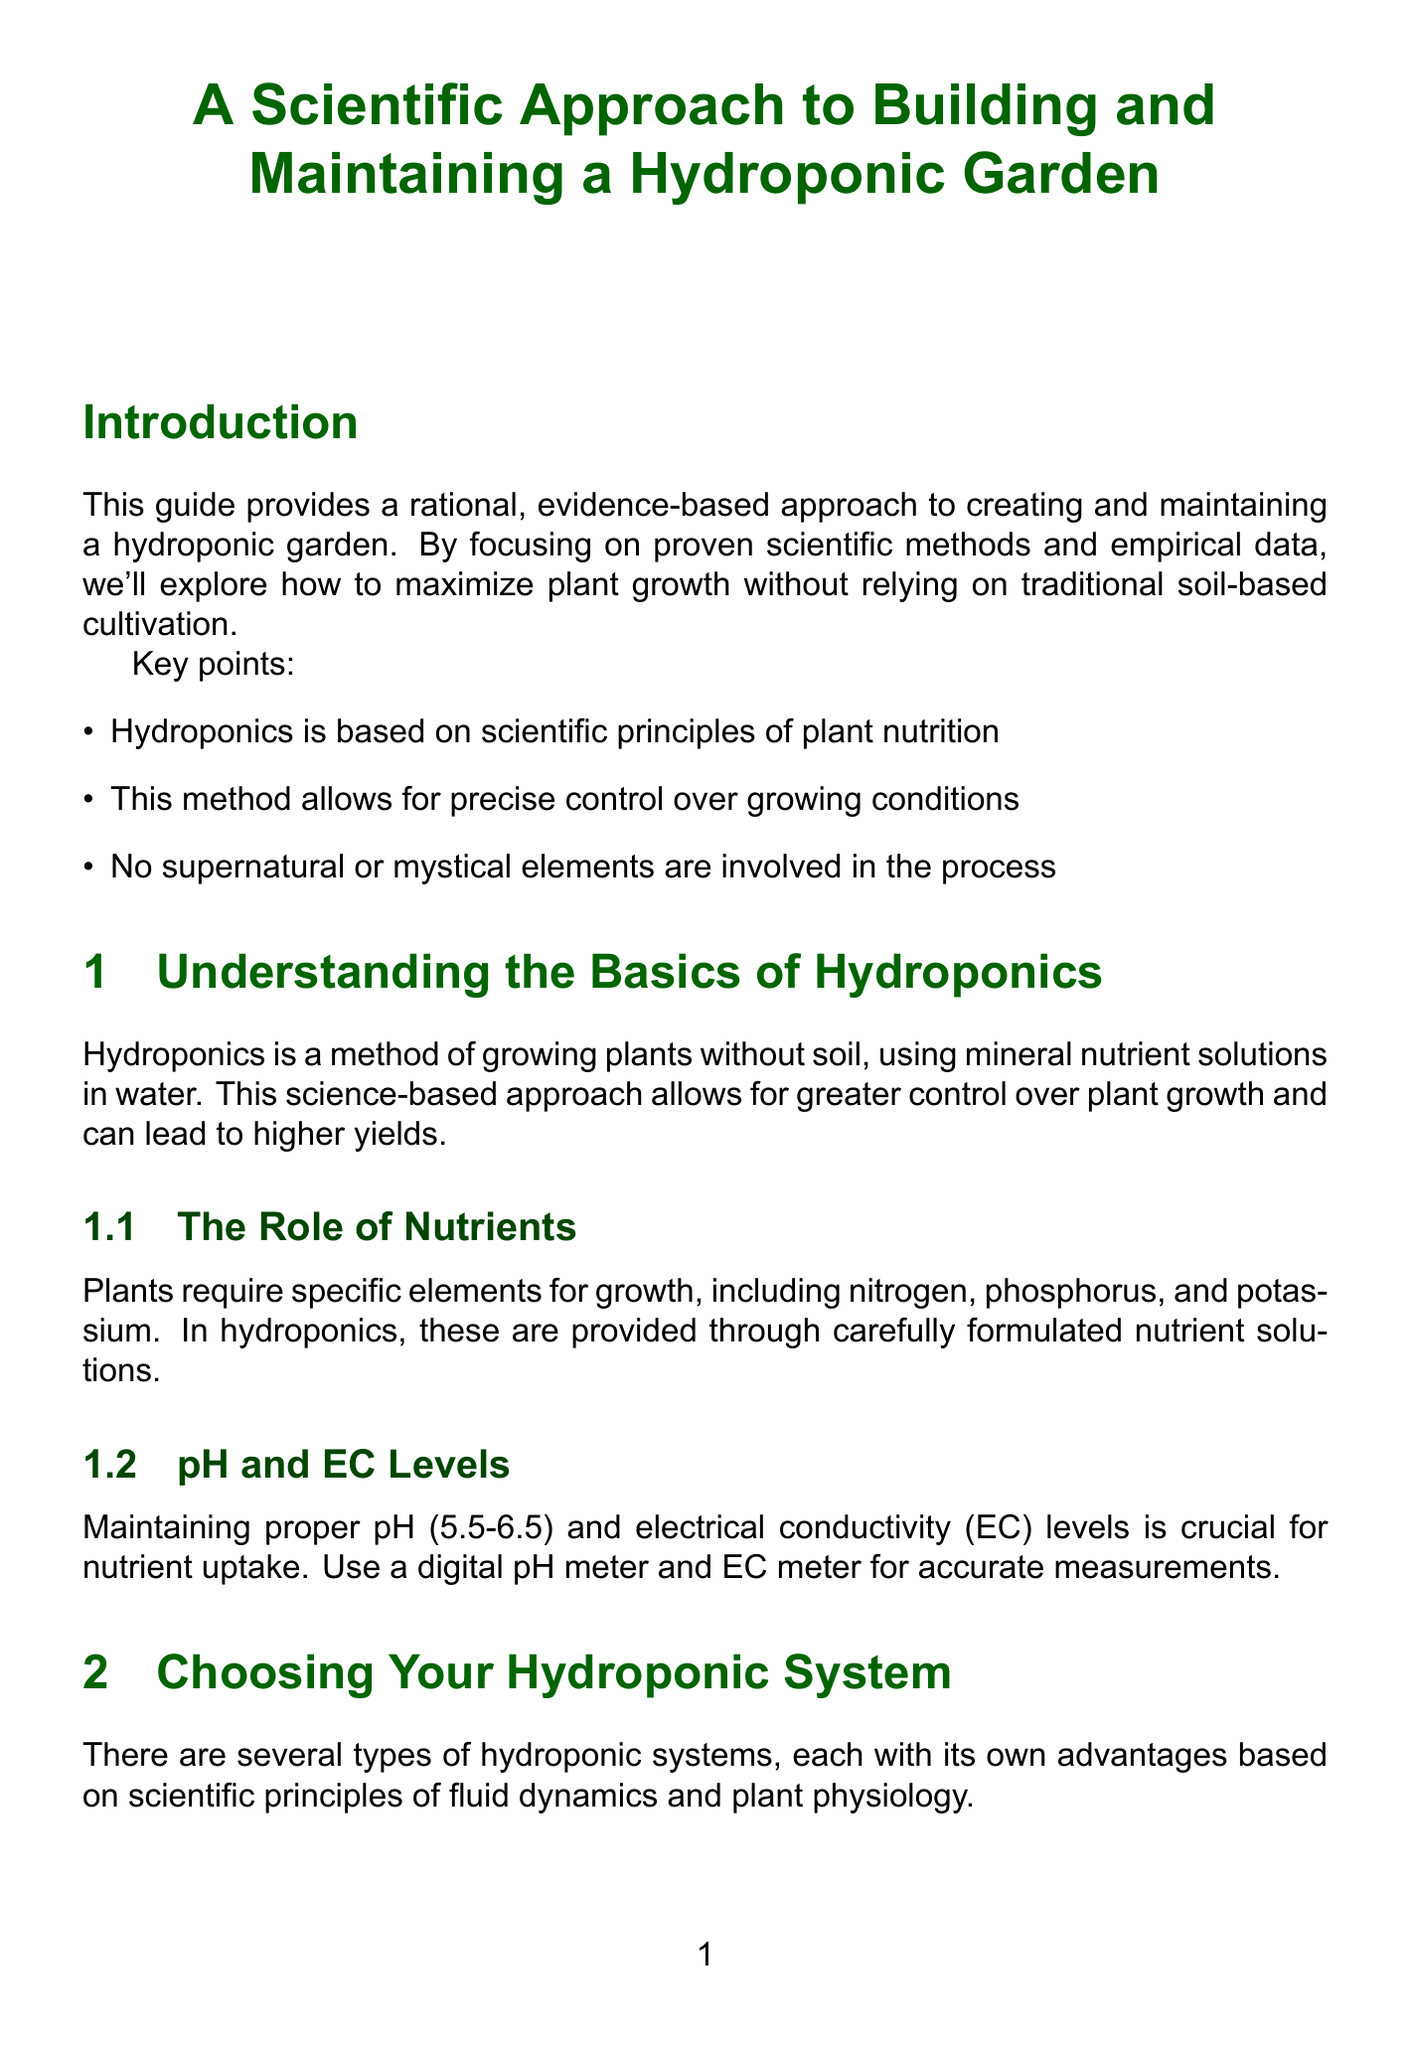what is the optimal pH range for hydroponics? The optimal pH range for hydroponics is crucial for nutrient uptake, which is 5.5-6.5.
Answer: 5.5-6.5 what type of plants are well-suited for hydroponic growth? Well-suited plants include leafy greens, herbs, and certain fruiting plants.
Answer: leafy greens, herbs, certain fruiting plants how many steps are involved in setting up a hydroponic garden? The process of setting up a hydroponic garden includes a series of clear steps outlined in the document.
Answer: 4 what is the frequency for checking pH levels? The document specifies that checking pH levels is a daily task for maintaining the hydroponic garden.
Answer: daily what is the purpose of a digital pH meter? A digital pH meter is important for maintaining proper pH levels in the nutrient solution for optimal plant growth.
Answer: accurate measurements what system uses periodic flooding and draining? The Ebb and Flow system is based on periodic flooding and draining of the growing medium.
Answer: Ebb and Flow what is recommended to combat root rot in hydroponics? The solution to address root rot involves increasing oxygen levels in the nutrient solution and possibly introducing beneficial bacteria.
Answer: increase oxygen levels what should you do after harvesting your plants? After harvesting, thorough cleaning and sanitization of the hydroponic system is recommended before starting the next crop cycle.
Answer: clean and sanitize the system 